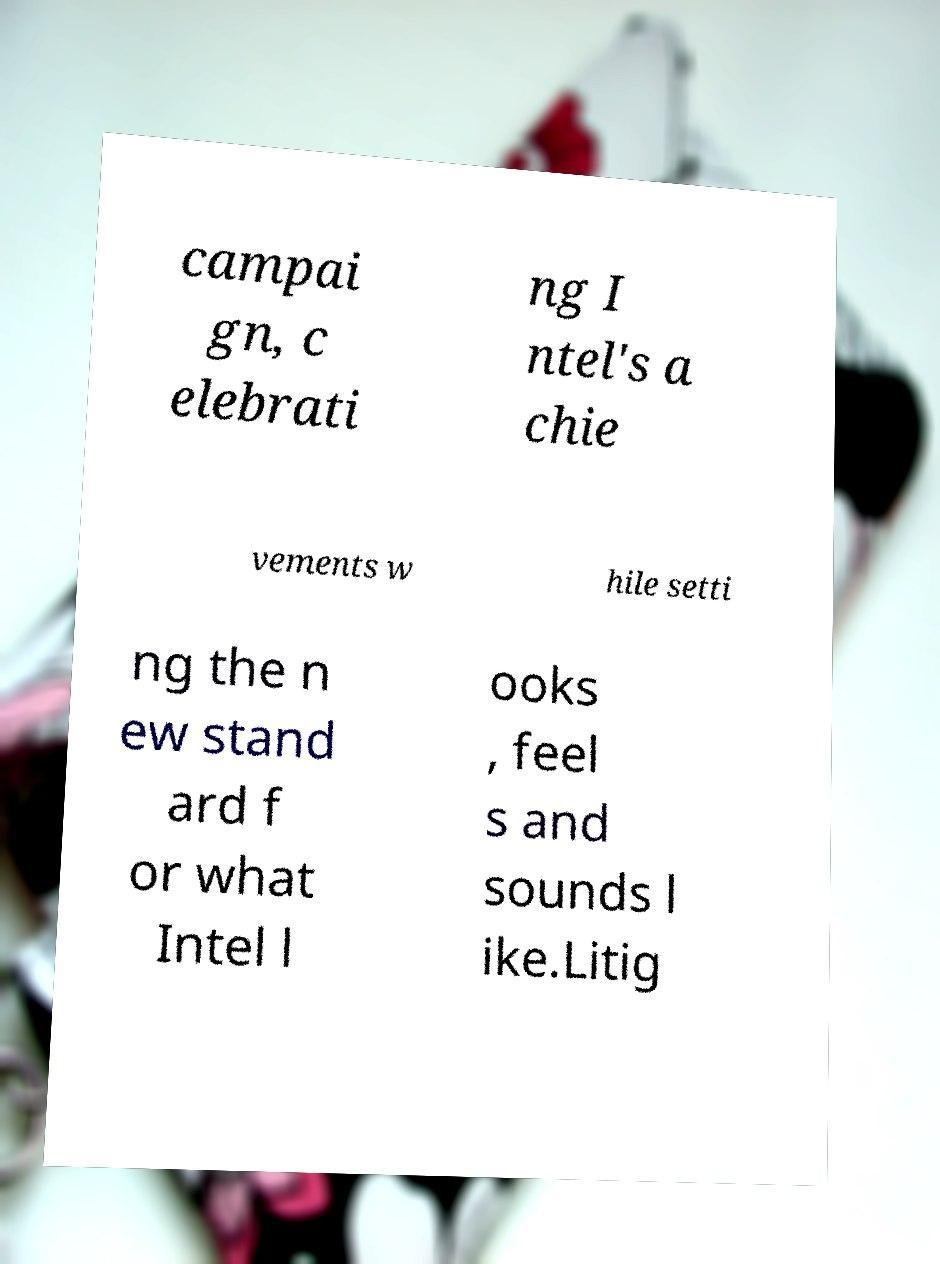Please read and relay the text visible in this image. What does it say? campai gn, c elebrati ng I ntel's a chie vements w hile setti ng the n ew stand ard f or what Intel l ooks , feel s and sounds l ike.Litig 